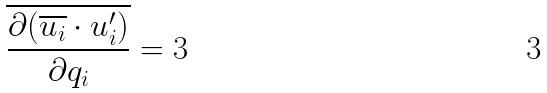Convert formula to latex. <formula><loc_0><loc_0><loc_500><loc_500>\overline { \frac { \partial ( \overline { u _ { i } } \cdot u _ { i } ^ { \prime } ) } { \partial q _ { i } } } = 3</formula> 